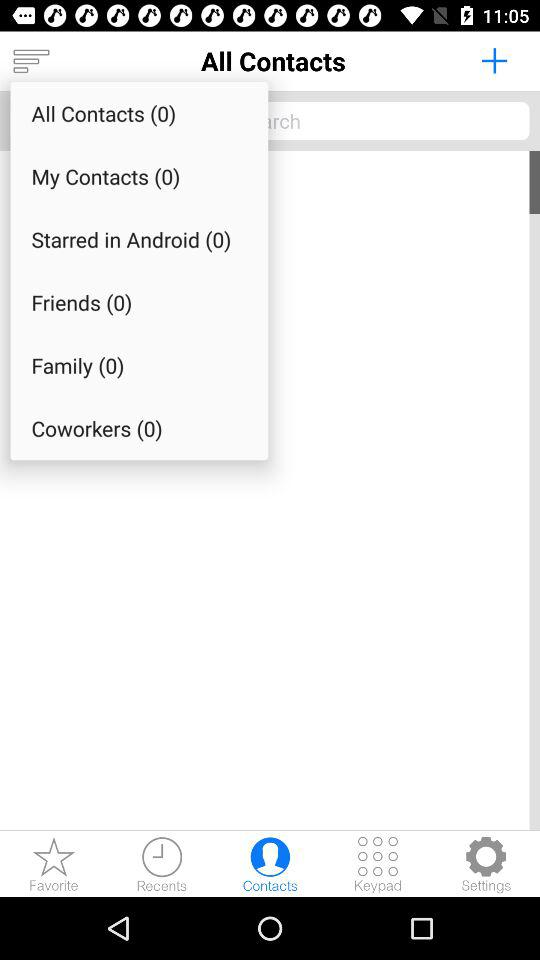What is the selected tab? The tab "Contacts" is selected. 